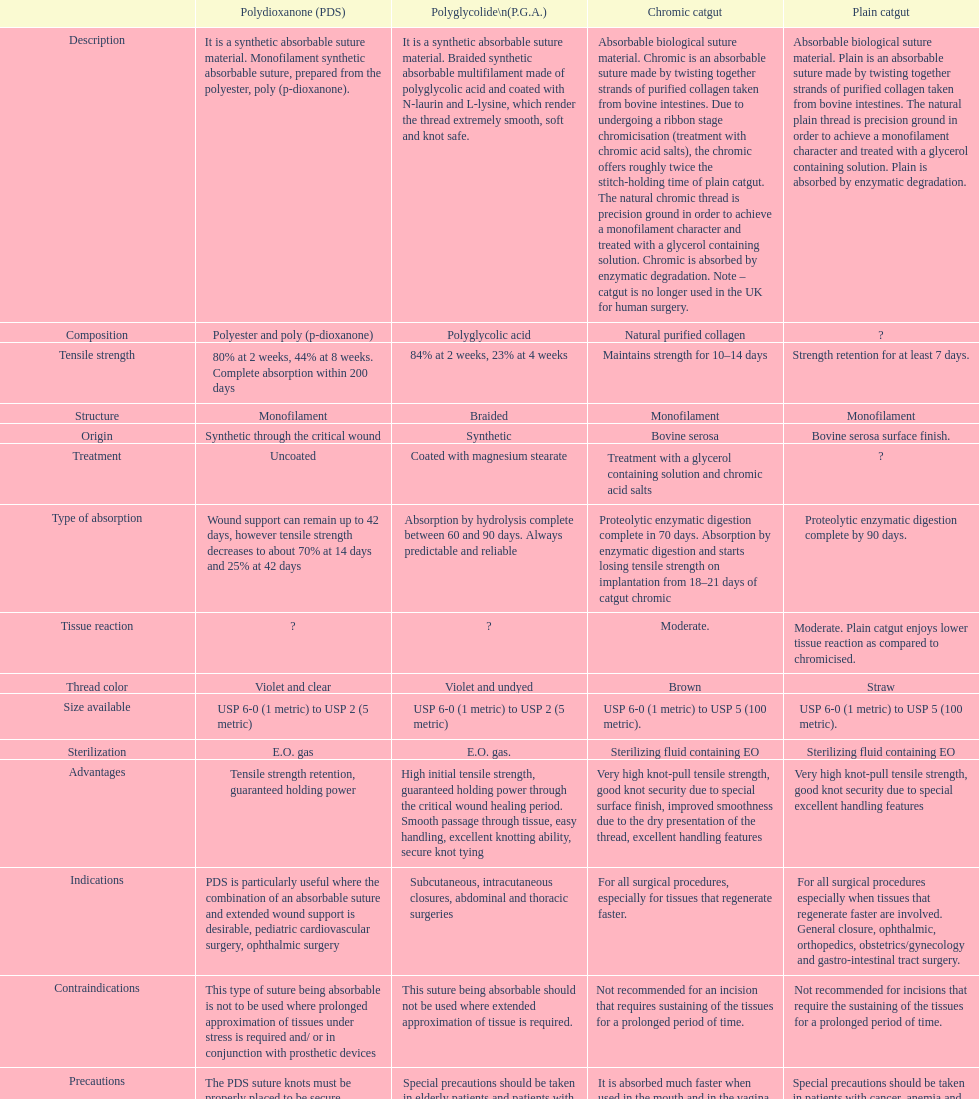Plain catgut and chromic catgut both have what type of structure? Monofilament. 